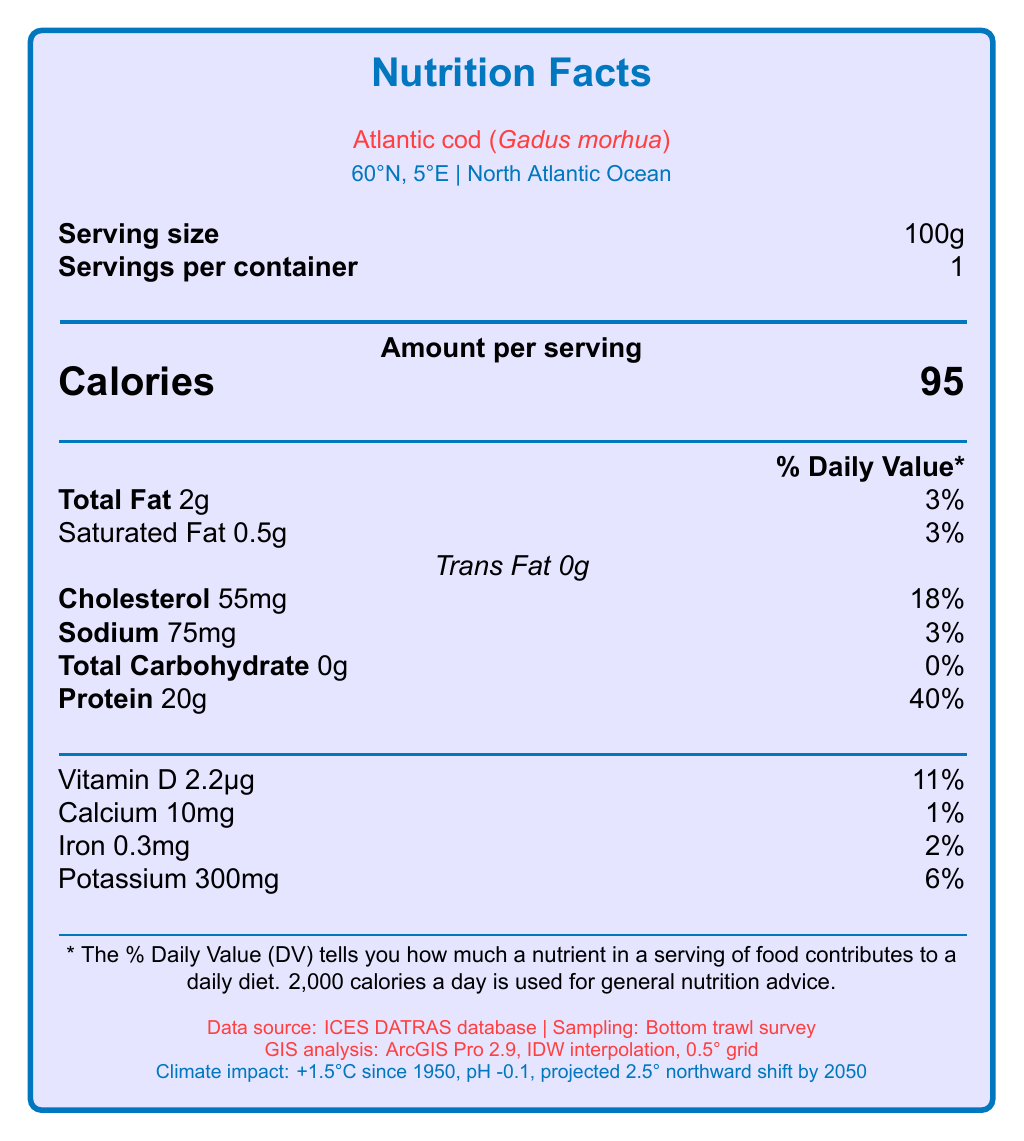What is the serving size of Atlantic cod mentioned in the document? The highlighted section at the beginning of the document states that the serving size is 100g.
Answer: 100g How many calories are there per serving? The "Amount per serving" section specifies that there are 95 calories per serving.
Answer: 95 calories What percentage of the daily value for cholesterol does one serving provide? The document indicates that one serving provides 18% of the daily value for cholesterol.
Answer: 18% Which nutrient has the highest daily value percentage in one serving? The document shows that protein has a daily value percentage of 40%, which is the highest among the listed nutrients.
Answer: Protein What is the total amount of fat in one serving? The "Total Fat" section shows that one serving contains 2g of total fat.
Answer: 2g Which latitude and longitude coordinates are provided in the document? The geographical coordinates 60°N latitude and 5°E longitude are specified in the document.
Answer: 60°N, 5°E What software was used for GIS analysis in this study? The document mentions that ArcGIS Pro 2.9 was used for GIS analysis.
Answer: ArcGIS Pro 2.9 What is the projected northward migration for Atlantic cod by 2050? The climate change impact section notes that there is a projected northward migration of 2.5° latitude by 2050.
Answer: 2.5° latitude Which nutrient amounts to 300mg per serving according to the document? The vitamins and minerals section shows that potassium amounts to 300mg per serving.
Answer: Potassium What are the related datasets mentioned in the document? The document lists these datasets in the related datasets section.
Answer: Sea Surface Temperature (SST) from NOAA OISST, Chlorophyll-a concentration from NASA MODIS-Aqua, Bathymetry data from GEBCO What sampling method was used for collecting data? The document states that a bottom trawl survey was the sampling method used.
Answer: Bottom trawl survey Which collaborative effort is NOT mentioned in the document? (A) ICES Working Group on Cod and Climate Change, (B) PICES Section on Climate Change Effects on Marine Ecosystems, (C) NANOOS Harmful Algal Bloom Program, (D) EU Horizon 2020 project: ClimeFish Collaborative efforts A, B, and D are mentioned, but C is not mentioned in the document.
Answer: C. NANOOS Harmful Algal Bloom Program Which nutrient has the lowest daily value percentage in one serving? (a) Calcium, (b) Iron, (c) Vitamin D, (d) Sodium Calcium has a daily value percentage of 1%, which is the lowest compared to Iron (2%), Vitamin D (11%), and Sodium (3%) listed in the document.
Answer: (a) Calcium Is there any information about trans fat content in the document? The nutrient section indicates that the trans fat content is 0g.
Answer: Yes Summarize the main idea of the document. The document highlights both the nutritional aspects and the scientific context of Atlantic cod in relation to environmental factors and research collaborations.
Answer: The document provides nutritional information for Atlantic cod (Gadus morhua), including serving size, caloric content, and nutrient breakdown. It also outlines the GIS analysis methods used, the climate change impacts on the species, ecological implications, related datasets, and collaborative efforts. What is the exact temperature increase noted in the documents as a result of climate change? The climate change impact section mentions that the temperature has increased by +1.5°C since 1950.
Answer: +1.5°C since 1950 What is the primary habitat of the Atlantic cod according to the document? The habitat of the Atlantic cod is specified as the North Atlantic Ocean.
Answer: North Atlantic Ocean Does the document provide information about the protein content in Atlantic cod? The document states that the protein content per serving is 20g.
Answer: Yes Who is funding the research mentioned in the document? The document does not provide specific information regarding the funding of the research.
Answer: Cannot be determined 